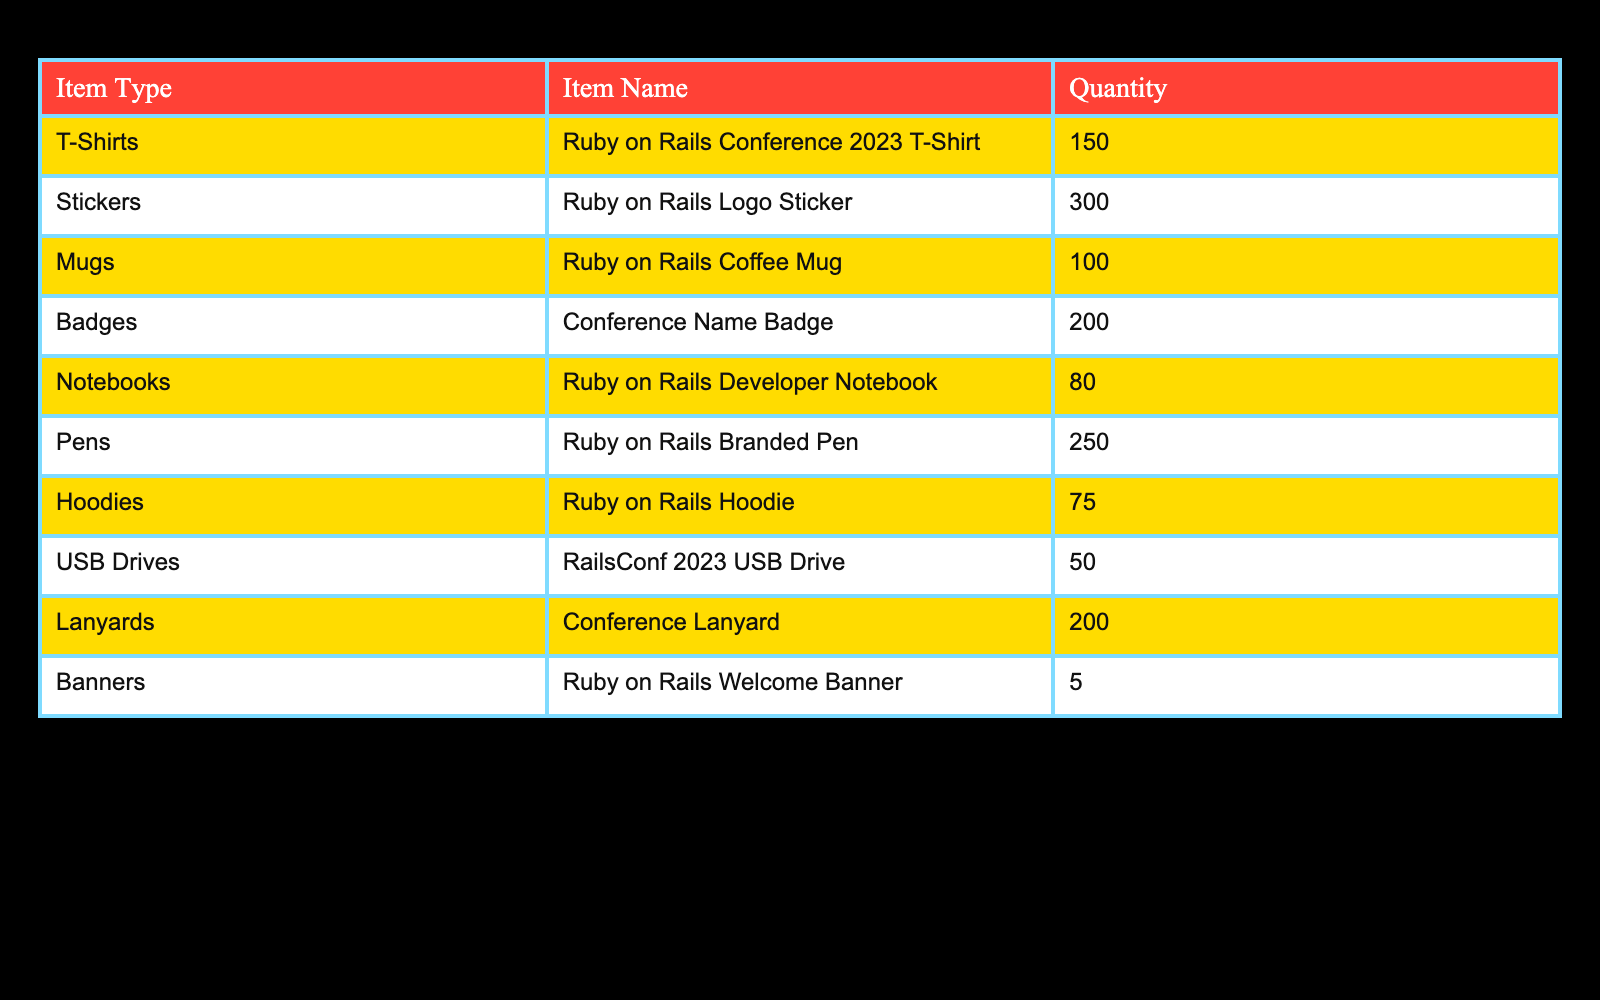What is the total quantity of T-Shirts available? The table shows that there are 150 T-Shirts available under the item name "Ruby on Rails Conference 2023 T-Shirt."
Answer: 150 How many more stickers are there than mugs? From the table, there are 300 stickers and 100 mugs. The difference is calculated as 300 - 100 = 200.
Answer: 200 Is the quantity of USB Drives greater than the quantity of Hoodies? The table lists 50 USB Drives and 75 Hoodies. Since 50 is less than 75, the statement is false.
Answer: No What is the total quantity of all items listed? Each item's quantity is summed: 150 (T-Shirts) + 300 (Stickers) + 100 (Mugs) + 200 (Badges) + 80 (Notebooks) + 250 (Pens) + 75 (Hoodies) + 50 (USB Drives) + 200 (Lanyards) + 5 (Banners) = 1210.
Answer: 1210 Which item type has the least quantity? By reviewing the table, the item type "Banners" has the least quantity with only 5 available.
Answer: Banners 